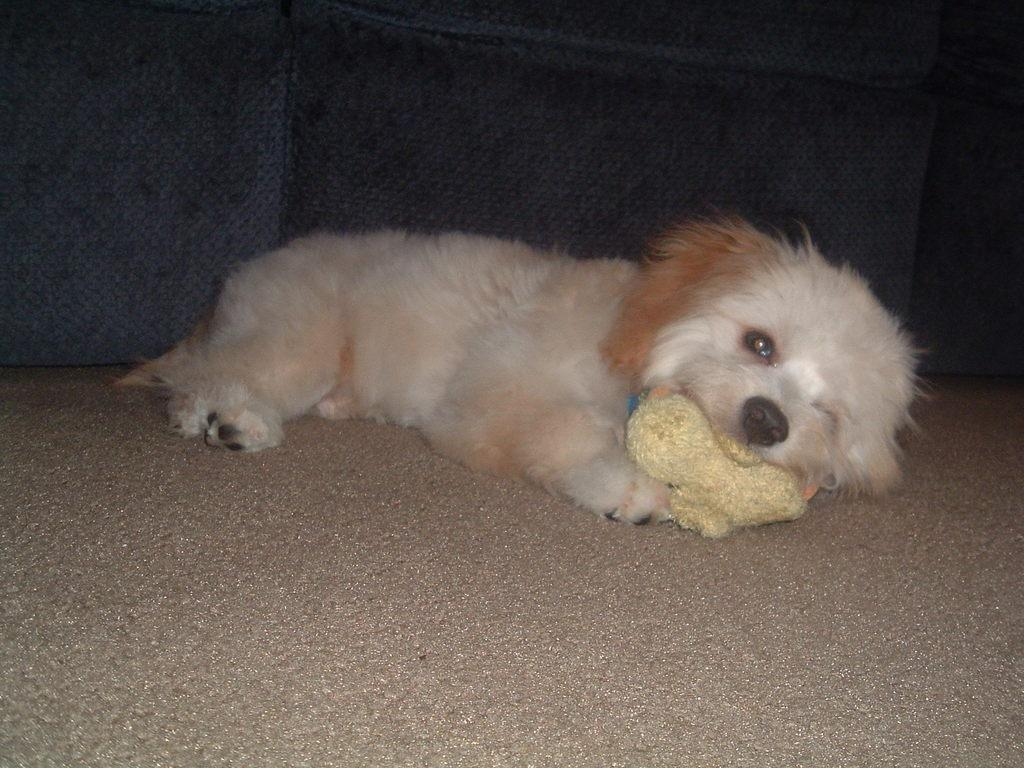What animal is present in the image? There is a dog in the image. Where is the dog located? The dog is on a sofa. What is the title of the book on the shelf in the image? There is no book or shelf present in the image; it only features a dog on a sofa. 